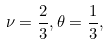<formula> <loc_0><loc_0><loc_500><loc_500>\nu = \frac { 2 } { 3 } , \theta = \frac { 1 } { 3 } ,</formula> 